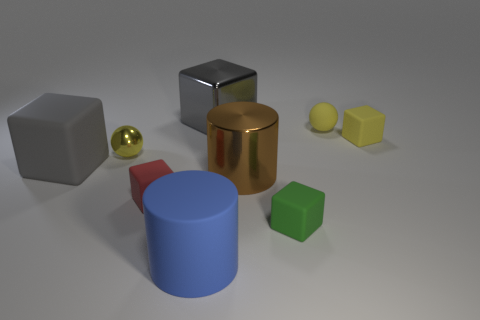Can you describe the different objects and their materials in the picture? Certainly. In the image, we observe various geometric shapes each likely representing different materials. Beginning from the left, there is a white cube that appears to have a matte texture which could be plastic or ceramic. Next, there is a small, shiny gold sphere, suggesting a polished metal. The tall, brown cylinder in the center resembles a brushed metal, perhaps copper or bronze. Behind it lies a large sphere with a reflective chrome finish, indicating a mirrored metal surface. On the right, there are two small objects: the yellow cube resembles a light, possibly plastic material, whereas the small yellow sphere has a similar finish to the cube, implying a comparable material. 